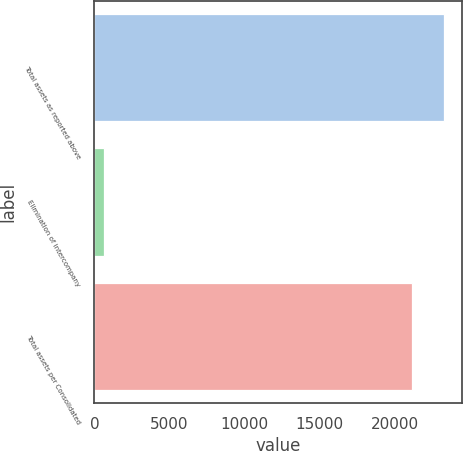<chart> <loc_0><loc_0><loc_500><loc_500><bar_chart><fcel>Total assets as reported above<fcel>Elimination of intercompany<fcel>Total assets per Consolidated<nl><fcel>23269.4<fcel>647<fcel>21154<nl></chart> 